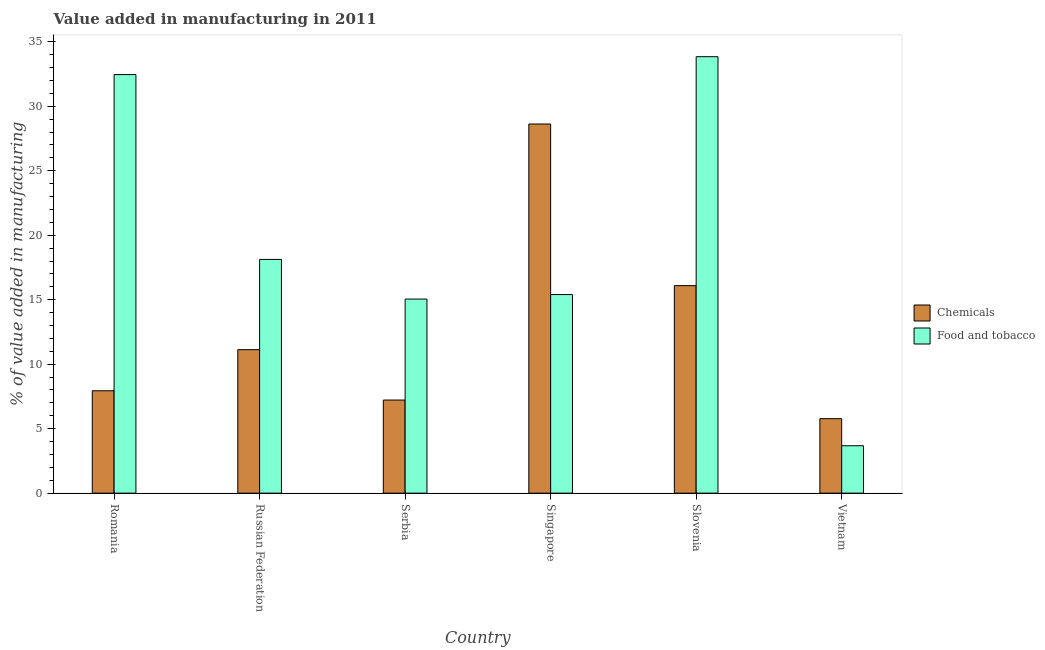Are the number of bars on each tick of the X-axis equal?
Keep it short and to the point. Yes. What is the label of the 1st group of bars from the left?
Make the answer very short. Romania. What is the value added by manufacturing food and tobacco in Slovenia?
Give a very brief answer. 33.84. Across all countries, what is the maximum value added by manufacturing food and tobacco?
Provide a succinct answer. 33.84. Across all countries, what is the minimum value added by  manufacturing chemicals?
Your answer should be compact. 5.78. In which country was the value added by  manufacturing chemicals maximum?
Keep it short and to the point. Singapore. In which country was the value added by  manufacturing chemicals minimum?
Make the answer very short. Vietnam. What is the total value added by manufacturing food and tobacco in the graph?
Your answer should be compact. 118.55. What is the difference between the value added by manufacturing food and tobacco in Romania and that in Serbia?
Your answer should be very brief. 17.41. What is the difference between the value added by manufacturing food and tobacco in Vietnam and the value added by  manufacturing chemicals in Russian Federation?
Your answer should be compact. -7.45. What is the average value added by manufacturing food and tobacco per country?
Provide a short and direct response. 19.76. What is the difference between the value added by manufacturing food and tobacco and value added by  manufacturing chemicals in Singapore?
Offer a terse response. -13.22. In how many countries, is the value added by  manufacturing chemicals greater than 8 %?
Offer a very short reply. 3. What is the ratio of the value added by  manufacturing chemicals in Romania to that in Vietnam?
Ensure brevity in your answer.  1.37. Is the value added by  manufacturing chemicals in Slovenia less than that in Vietnam?
Offer a terse response. No. Is the difference between the value added by  manufacturing chemicals in Romania and Russian Federation greater than the difference between the value added by manufacturing food and tobacco in Romania and Russian Federation?
Keep it short and to the point. No. What is the difference between the highest and the second highest value added by  manufacturing chemicals?
Give a very brief answer. 12.53. What is the difference between the highest and the lowest value added by  manufacturing chemicals?
Your response must be concise. 22.85. Is the sum of the value added by manufacturing food and tobacco in Romania and Serbia greater than the maximum value added by  manufacturing chemicals across all countries?
Ensure brevity in your answer.  Yes. What does the 1st bar from the left in Vietnam represents?
Keep it short and to the point. Chemicals. What does the 2nd bar from the right in Slovenia represents?
Provide a short and direct response. Chemicals. What is the difference between two consecutive major ticks on the Y-axis?
Your answer should be very brief. 5. Does the graph contain any zero values?
Your answer should be compact. No. Does the graph contain grids?
Your response must be concise. No. How many legend labels are there?
Offer a very short reply. 2. How are the legend labels stacked?
Your answer should be compact. Vertical. What is the title of the graph?
Make the answer very short. Value added in manufacturing in 2011. What is the label or title of the X-axis?
Provide a short and direct response. Country. What is the label or title of the Y-axis?
Give a very brief answer. % of value added in manufacturing. What is the % of value added in manufacturing in Chemicals in Romania?
Offer a terse response. 7.94. What is the % of value added in manufacturing in Food and tobacco in Romania?
Provide a short and direct response. 32.46. What is the % of value added in manufacturing of Chemicals in Russian Federation?
Provide a short and direct response. 11.13. What is the % of value added in manufacturing of Food and tobacco in Russian Federation?
Your answer should be compact. 18.12. What is the % of value added in manufacturing of Chemicals in Serbia?
Ensure brevity in your answer.  7.22. What is the % of value added in manufacturing of Food and tobacco in Serbia?
Your response must be concise. 15.05. What is the % of value added in manufacturing in Chemicals in Singapore?
Ensure brevity in your answer.  28.62. What is the % of value added in manufacturing of Food and tobacco in Singapore?
Your answer should be compact. 15.4. What is the % of value added in manufacturing of Chemicals in Slovenia?
Your answer should be compact. 16.09. What is the % of value added in manufacturing in Food and tobacco in Slovenia?
Keep it short and to the point. 33.84. What is the % of value added in manufacturing in Chemicals in Vietnam?
Keep it short and to the point. 5.78. What is the % of value added in manufacturing in Food and tobacco in Vietnam?
Offer a terse response. 3.68. Across all countries, what is the maximum % of value added in manufacturing of Chemicals?
Your response must be concise. 28.62. Across all countries, what is the maximum % of value added in manufacturing of Food and tobacco?
Make the answer very short. 33.84. Across all countries, what is the minimum % of value added in manufacturing of Chemicals?
Your response must be concise. 5.78. Across all countries, what is the minimum % of value added in manufacturing in Food and tobacco?
Give a very brief answer. 3.68. What is the total % of value added in manufacturing of Chemicals in the graph?
Your answer should be very brief. 76.77. What is the total % of value added in manufacturing of Food and tobacco in the graph?
Make the answer very short. 118.55. What is the difference between the % of value added in manufacturing in Chemicals in Romania and that in Russian Federation?
Your answer should be very brief. -3.19. What is the difference between the % of value added in manufacturing in Food and tobacco in Romania and that in Russian Federation?
Offer a terse response. 14.33. What is the difference between the % of value added in manufacturing in Chemicals in Romania and that in Serbia?
Your answer should be very brief. 0.72. What is the difference between the % of value added in manufacturing of Food and tobacco in Romania and that in Serbia?
Give a very brief answer. 17.41. What is the difference between the % of value added in manufacturing in Chemicals in Romania and that in Singapore?
Your answer should be very brief. -20.69. What is the difference between the % of value added in manufacturing of Food and tobacco in Romania and that in Singapore?
Provide a succinct answer. 17.06. What is the difference between the % of value added in manufacturing of Chemicals in Romania and that in Slovenia?
Your answer should be compact. -8.15. What is the difference between the % of value added in manufacturing of Food and tobacco in Romania and that in Slovenia?
Keep it short and to the point. -1.39. What is the difference between the % of value added in manufacturing of Chemicals in Romania and that in Vietnam?
Your answer should be very brief. 2.16. What is the difference between the % of value added in manufacturing of Food and tobacco in Romania and that in Vietnam?
Offer a very short reply. 28.78. What is the difference between the % of value added in manufacturing of Chemicals in Russian Federation and that in Serbia?
Provide a short and direct response. 3.91. What is the difference between the % of value added in manufacturing of Food and tobacco in Russian Federation and that in Serbia?
Give a very brief answer. 3.07. What is the difference between the % of value added in manufacturing in Chemicals in Russian Federation and that in Singapore?
Your answer should be compact. -17.5. What is the difference between the % of value added in manufacturing in Food and tobacco in Russian Federation and that in Singapore?
Ensure brevity in your answer.  2.72. What is the difference between the % of value added in manufacturing in Chemicals in Russian Federation and that in Slovenia?
Offer a very short reply. -4.96. What is the difference between the % of value added in manufacturing of Food and tobacco in Russian Federation and that in Slovenia?
Keep it short and to the point. -15.72. What is the difference between the % of value added in manufacturing of Chemicals in Russian Federation and that in Vietnam?
Provide a succinct answer. 5.35. What is the difference between the % of value added in manufacturing of Food and tobacco in Russian Federation and that in Vietnam?
Offer a very short reply. 14.45. What is the difference between the % of value added in manufacturing of Chemicals in Serbia and that in Singapore?
Provide a short and direct response. -21.4. What is the difference between the % of value added in manufacturing in Food and tobacco in Serbia and that in Singapore?
Ensure brevity in your answer.  -0.35. What is the difference between the % of value added in manufacturing of Chemicals in Serbia and that in Slovenia?
Keep it short and to the point. -8.87. What is the difference between the % of value added in manufacturing of Food and tobacco in Serbia and that in Slovenia?
Your response must be concise. -18.79. What is the difference between the % of value added in manufacturing in Chemicals in Serbia and that in Vietnam?
Make the answer very short. 1.44. What is the difference between the % of value added in manufacturing in Food and tobacco in Serbia and that in Vietnam?
Offer a very short reply. 11.37. What is the difference between the % of value added in manufacturing in Chemicals in Singapore and that in Slovenia?
Provide a succinct answer. 12.53. What is the difference between the % of value added in manufacturing of Food and tobacco in Singapore and that in Slovenia?
Your answer should be very brief. -18.44. What is the difference between the % of value added in manufacturing of Chemicals in Singapore and that in Vietnam?
Give a very brief answer. 22.85. What is the difference between the % of value added in manufacturing in Food and tobacco in Singapore and that in Vietnam?
Offer a very short reply. 11.72. What is the difference between the % of value added in manufacturing of Chemicals in Slovenia and that in Vietnam?
Give a very brief answer. 10.32. What is the difference between the % of value added in manufacturing in Food and tobacco in Slovenia and that in Vietnam?
Your answer should be very brief. 30.17. What is the difference between the % of value added in manufacturing in Chemicals in Romania and the % of value added in manufacturing in Food and tobacco in Russian Federation?
Give a very brief answer. -10.19. What is the difference between the % of value added in manufacturing in Chemicals in Romania and the % of value added in manufacturing in Food and tobacco in Serbia?
Give a very brief answer. -7.11. What is the difference between the % of value added in manufacturing of Chemicals in Romania and the % of value added in manufacturing of Food and tobacco in Singapore?
Ensure brevity in your answer.  -7.46. What is the difference between the % of value added in manufacturing in Chemicals in Romania and the % of value added in manufacturing in Food and tobacco in Slovenia?
Give a very brief answer. -25.9. What is the difference between the % of value added in manufacturing of Chemicals in Romania and the % of value added in manufacturing of Food and tobacco in Vietnam?
Your answer should be very brief. 4.26. What is the difference between the % of value added in manufacturing of Chemicals in Russian Federation and the % of value added in manufacturing of Food and tobacco in Serbia?
Provide a short and direct response. -3.92. What is the difference between the % of value added in manufacturing in Chemicals in Russian Federation and the % of value added in manufacturing in Food and tobacco in Singapore?
Your response must be concise. -4.27. What is the difference between the % of value added in manufacturing in Chemicals in Russian Federation and the % of value added in manufacturing in Food and tobacco in Slovenia?
Make the answer very short. -22.72. What is the difference between the % of value added in manufacturing in Chemicals in Russian Federation and the % of value added in manufacturing in Food and tobacco in Vietnam?
Ensure brevity in your answer.  7.45. What is the difference between the % of value added in manufacturing in Chemicals in Serbia and the % of value added in manufacturing in Food and tobacco in Singapore?
Offer a terse response. -8.18. What is the difference between the % of value added in manufacturing in Chemicals in Serbia and the % of value added in manufacturing in Food and tobacco in Slovenia?
Provide a succinct answer. -26.62. What is the difference between the % of value added in manufacturing of Chemicals in Serbia and the % of value added in manufacturing of Food and tobacco in Vietnam?
Offer a very short reply. 3.54. What is the difference between the % of value added in manufacturing in Chemicals in Singapore and the % of value added in manufacturing in Food and tobacco in Slovenia?
Provide a short and direct response. -5.22. What is the difference between the % of value added in manufacturing in Chemicals in Singapore and the % of value added in manufacturing in Food and tobacco in Vietnam?
Make the answer very short. 24.95. What is the difference between the % of value added in manufacturing in Chemicals in Slovenia and the % of value added in manufacturing in Food and tobacco in Vietnam?
Your answer should be very brief. 12.42. What is the average % of value added in manufacturing of Chemicals per country?
Ensure brevity in your answer.  12.8. What is the average % of value added in manufacturing in Food and tobacco per country?
Keep it short and to the point. 19.76. What is the difference between the % of value added in manufacturing of Chemicals and % of value added in manufacturing of Food and tobacco in Romania?
Your response must be concise. -24.52. What is the difference between the % of value added in manufacturing in Chemicals and % of value added in manufacturing in Food and tobacco in Russian Federation?
Keep it short and to the point. -7. What is the difference between the % of value added in manufacturing of Chemicals and % of value added in manufacturing of Food and tobacco in Serbia?
Your response must be concise. -7.83. What is the difference between the % of value added in manufacturing in Chemicals and % of value added in manufacturing in Food and tobacco in Singapore?
Your answer should be very brief. 13.22. What is the difference between the % of value added in manufacturing of Chemicals and % of value added in manufacturing of Food and tobacco in Slovenia?
Provide a short and direct response. -17.75. What is the difference between the % of value added in manufacturing in Chemicals and % of value added in manufacturing in Food and tobacco in Vietnam?
Provide a succinct answer. 2.1. What is the ratio of the % of value added in manufacturing of Chemicals in Romania to that in Russian Federation?
Provide a succinct answer. 0.71. What is the ratio of the % of value added in manufacturing of Food and tobacco in Romania to that in Russian Federation?
Provide a short and direct response. 1.79. What is the ratio of the % of value added in manufacturing of Chemicals in Romania to that in Serbia?
Keep it short and to the point. 1.1. What is the ratio of the % of value added in manufacturing of Food and tobacco in Romania to that in Serbia?
Offer a very short reply. 2.16. What is the ratio of the % of value added in manufacturing of Chemicals in Romania to that in Singapore?
Your answer should be compact. 0.28. What is the ratio of the % of value added in manufacturing of Food and tobacco in Romania to that in Singapore?
Provide a succinct answer. 2.11. What is the ratio of the % of value added in manufacturing in Chemicals in Romania to that in Slovenia?
Provide a succinct answer. 0.49. What is the ratio of the % of value added in manufacturing of Food and tobacco in Romania to that in Slovenia?
Ensure brevity in your answer.  0.96. What is the ratio of the % of value added in manufacturing of Chemicals in Romania to that in Vietnam?
Ensure brevity in your answer.  1.37. What is the ratio of the % of value added in manufacturing in Food and tobacco in Romania to that in Vietnam?
Make the answer very short. 8.83. What is the ratio of the % of value added in manufacturing in Chemicals in Russian Federation to that in Serbia?
Provide a succinct answer. 1.54. What is the ratio of the % of value added in manufacturing in Food and tobacco in Russian Federation to that in Serbia?
Ensure brevity in your answer.  1.2. What is the ratio of the % of value added in manufacturing of Chemicals in Russian Federation to that in Singapore?
Provide a succinct answer. 0.39. What is the ratio of the % of value added in manufacturing in Food and tobacco in Russian Federation to that in Singapore?
Provide a short and direct response. 1.18. What is the ratio of the % of value added in manufacturing in Chemicals in Russian Federation to that in Slovenia?
Make the answer very short. 0.69. What is the ratio of the % of value added in manufacturing of Food and tobacco in Russian Federation to that in Slovenia?
Offer a very short reply. 0.54. What is the ratio of the % of value added in manufacturing of Chemicals in Russian Federation to that in Vietnam?
Your answer should be very brief. 1.93. What is the ratio of the % of value added in manufacturing of Food and tobacco in Russian Federation to that in Vietnam?
Give a very brief answer. 4.93. What is the ratio of the % of value added in manufacturing in Chemicals in Serbia to that in Singapore?
Ensure brevity in your answer.  0.25. What is the ratio of the % of value added in manufacturing of Food and tobacco in Serbia to that in Singapore?
Provide a short and direct response. 0.98. What is the ratio of the % of value added in manufacturing of Chemicals in Serbia to that in Slovenia?
Provide a succinct answer. 0.45. What is the ratio of the % of value added in manufacturing in Food and tobacco in Serbia to that in Slovenia?
Provide a short and direct response. 0.44. What is the ratio of the % of value added in manufacturing of Chemicals in Serbia to that in Vietnam?
Provide a succinct answer. 1.25. What is the ratio of the % of value added in manufacturing of Food and tobacco in Serbia to that in Vietnam?
Provide a succinct answer. 4.09. What is the ratio of the % of value added in manufacturing of Chemicals in Singapore to that in Slovenia?
Keep it short and to the point. 1.78. What is the ratio of the % of value added in manufacturing of Food and tobacco in Singapore to that in Slovenia?
Make the answer very short. 0.46. What is the ratio of the % of value added in manufacturing in Chemicals in Singapore to that in Vietnam?
Keep it short and to the point. 4.96. What is the ratio of the % of value added in manufacturing in Food and tobacco in Singapore to that in Vietnam?
Your response must be concise. 4.19. What is the ratio of the % of value added in manufacturing of Chemicals in Slovenia to that in Vietnam?
Ensure brevity in your answer.  2.79. What is the ratio of the % of value added in manufacturing of Food and tobacco in Slovenia to that in Vietnam?
Your answer should be compact. 9.21. What is the difference between the highest and the second highest % of value added in manufacturing in Chemicals?
Your answer should be very brief. 12.53. What is the difference between the highest and the second highest % of value added in manufacturing of Food and tobacco?
Provide a succinct answer. 1.39. What is the difference between the highest and the lowest % of value added in manufacturing in Chemicals?
Provide a short and direct response. 22.85. What is the difference between the highest and the lowest % of value added in manufacturing of Food and tobacco?
Make the answer very short. 30.17. 